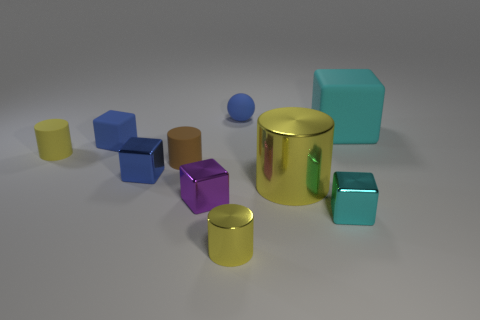Subtract all large yellow metallic cylinders. How many cylinders are left? 3 Subtract all blue spheres. How many blue cubes are left? 2 Subtract all brown cylinders. How many cylinders are left? 3 Subtract 1 blocks. How many blocks are left? 4 Subtract 1 brown cylinders. How many objects are left? 9 Subtract all balls. How many objects are left? 9 Subtract all yellow balls. Subtract all green cylinders. How many balls are left? 1 Subtract all cyan objects. Subtract all matte cylinders. How many objects are left? 6 Add 4 blue shiny objects. How many blue shiny objects are left? 5 Add 6 small green shiny spheres. How many small green shiny spheres exist? 6 